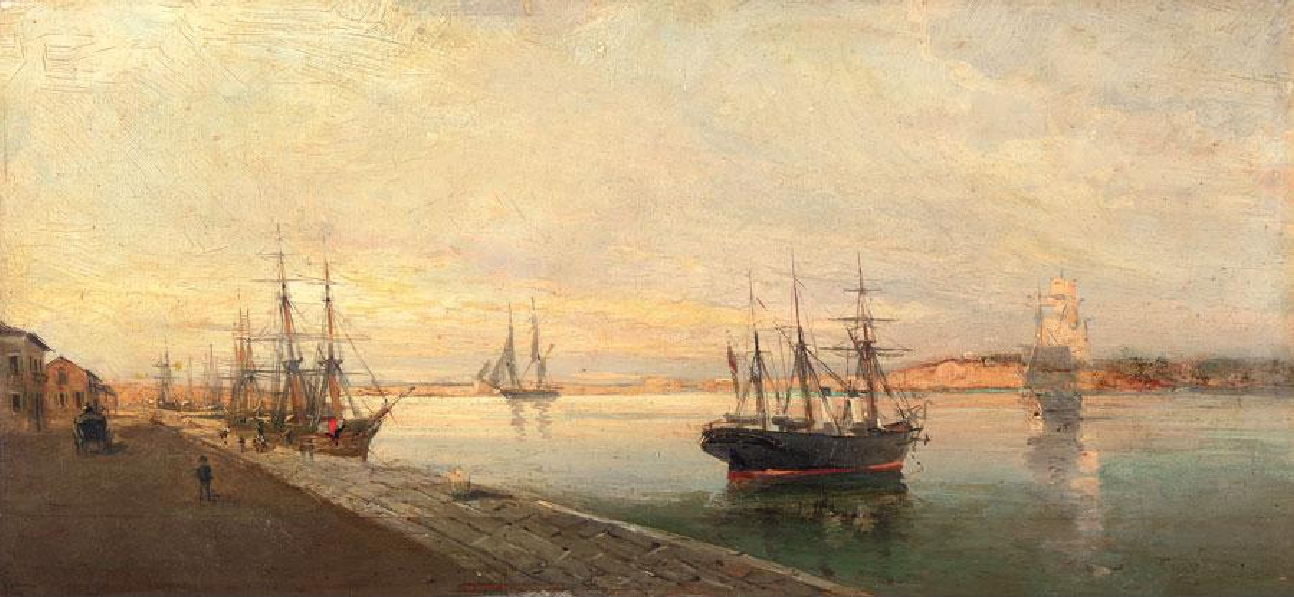Explain the visual content of the image in great detail. This oil painting illustrates a serene yet lively harbor scene. The artwork is replete with various ships and boats docked along the harbor, capturing a moment of bustling maritime activity. Employing an impressionist style, the artist utilizes loose brushstrokes to evoke the general ambiance and movement rather than meticulous detail. 

The color palette of the painting primarily features warm tones—shades of yellows, oranges, and browns—which instills a sense of warmth and light into the scene. This focus on light and color, hallmarks of the impressionist genre, contributes to the painting's overall atmospheric quality. 

Given the impressionist style and the subject matter, the painting likely dates back to the late 19th or early 20th century when impressionism was flourishing. Harbor scenes were a common theme during this period, serving as a canvas for impressionist artists to explore changing light and color in everyday settings. 

In summary, this painting beautifully encapsulates the essence of an impressionist harbor scene, teeming with light, color, and dynamic activity. 